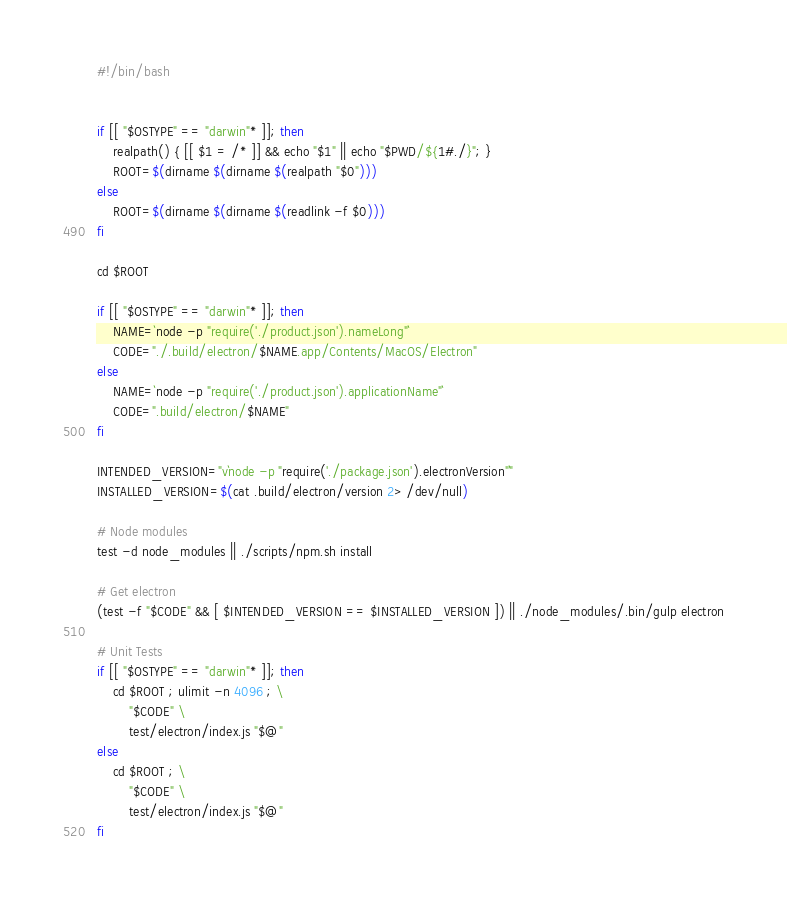<code> <loc_0><loc_0><loc_500><loc_500><_Bash_>#!/bin/bash


if [[ "$OSTYPE" == "darwin"* ]]; then
	realpath() { [[ $1 = /* ]] && echo "$1" || echo "$PWD/${1#./}"; }
	ROOT=$(dirname $(dirname $(realpath "$0")))
else
	ROOT=$(dirname $(dirname $(readlink -f $0)))
fi

cd $ROOT

if [[ "$OSTYPE" == "darwin"* ]]; then
	NAME=`node -p "require('./product.json').nameLong"`
	CODE="./.build/electron/$NAME.app/Contents/MacOS/Electron"
else
	NAME=`node -p "require('./product.json').applicationName"`
	CODE=".build/electron/$NAME"
fi

INTENDED_VERSION="v`node -p "require('./package.json').electronVersion"`"
INSTALLED_VERSION=$(cat .build/electron/version 2> /dev/null)

# Node modules
test -d node_modules || ./scripts/npm.sh install

# Get electron
(test -f "$CODE" && [ $INTENDED_VERSION == $INSTALLED_VERSION ]) || ./node_modules/.bin/gulp electron

# Unit Tests
if [[ "$OSTYPE" == "darwin"* ]]; then
	cd $ROOT ; ulimit -n 4096 ; \
		"$CODE" \
		test/electron/index.js "$@"
else
	cd $ROOT ; \
		"$CODE" \
		test/electron/index.js "$@"
fi
</code> 